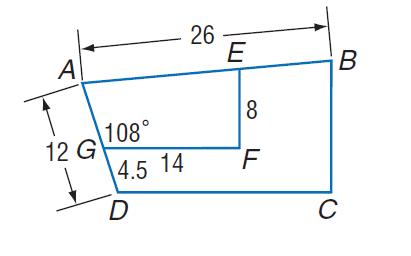Question: Polygon A B C D \sim polygon A E F G, m \angle A G F = 108, G F = 14, A D = 12, D G = 4.5, E F = 8, and A B = 26. Find the perimeter of trapezoid A B C D.
Choices:
A. 12
B. 52
C. 73.2
D. 100
Answer with the letter. Answer: C Question: Polygon A B C D \sim polygon A E F G, m \angle A G F = 108, G F = 14, A D = 12, D G = 4.5, E F = 8, and A B = 26. Find A G.
Choices:
A. 4.5
B. 7.5
C. 12
D. 20
Answer with the letter. Answer: B Question: Polygon A B C D \sim polygon A E F G, m \angle A G F = 108, G F = 14, A D = 12, D G = 4.5, E F = 8, and A B = 26. Find scale factor of trapezoid A B C D to trapezoid A E F G.
Choices:
A. 1.6
B. 4.5
C. 12
D. 26
Answer with the letter. Answer: A Question: Polygon A B C D \sim polygon A E F G, m \angle A G F = 108, G F = 14, A D = 12, D G = 4.5, E F = 8, and A B = 26. Find D C.
Choices:
A. 12
B. 14
C. 22.4
D. 26
Answer with the letter. Answer: C Question: Polygon A B C D \sim polygon A E F G, m \angle A G F = 108, G F = 14, A D = 12, D G = 4.5, E F = 8, and A B = 26. Find B C.
Choices:
A. 4.5
B. 12
C. 12.8
D. 100
Answer with the letter. Answer: C Question: Polygon A B C D \sim polygon A E F G, m \angle A G F = 108, G F = 14, A D = 12, D G = 4.5, E F = 8, and A B = 26. Find the perimeter of trapezoid A E F G.
Choices:
A. 4.575
B. 12
C. 26
D. 45.75
Answer with the letter. Answer: D 